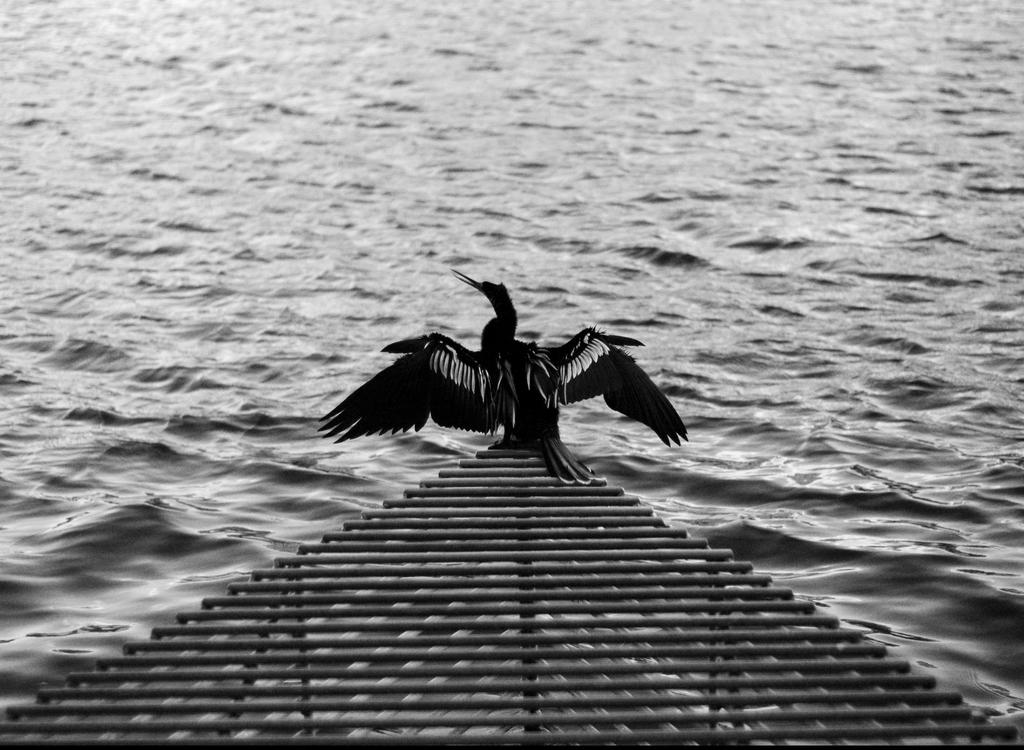What is the color scheme of the image? The image is black and white. What natural element can be seen in the image? There is water visible in the image. What type of animal is on the roof in the image? There is a bird on a roof in the image. Where is the roof located in the image? The roof is at the bottom of the image. What hobbies does the bird enjoy while swimming with a pen in the water? There is no indication in the image that the bird is swimming or using a pen, and therefore no such activities can be observed. 